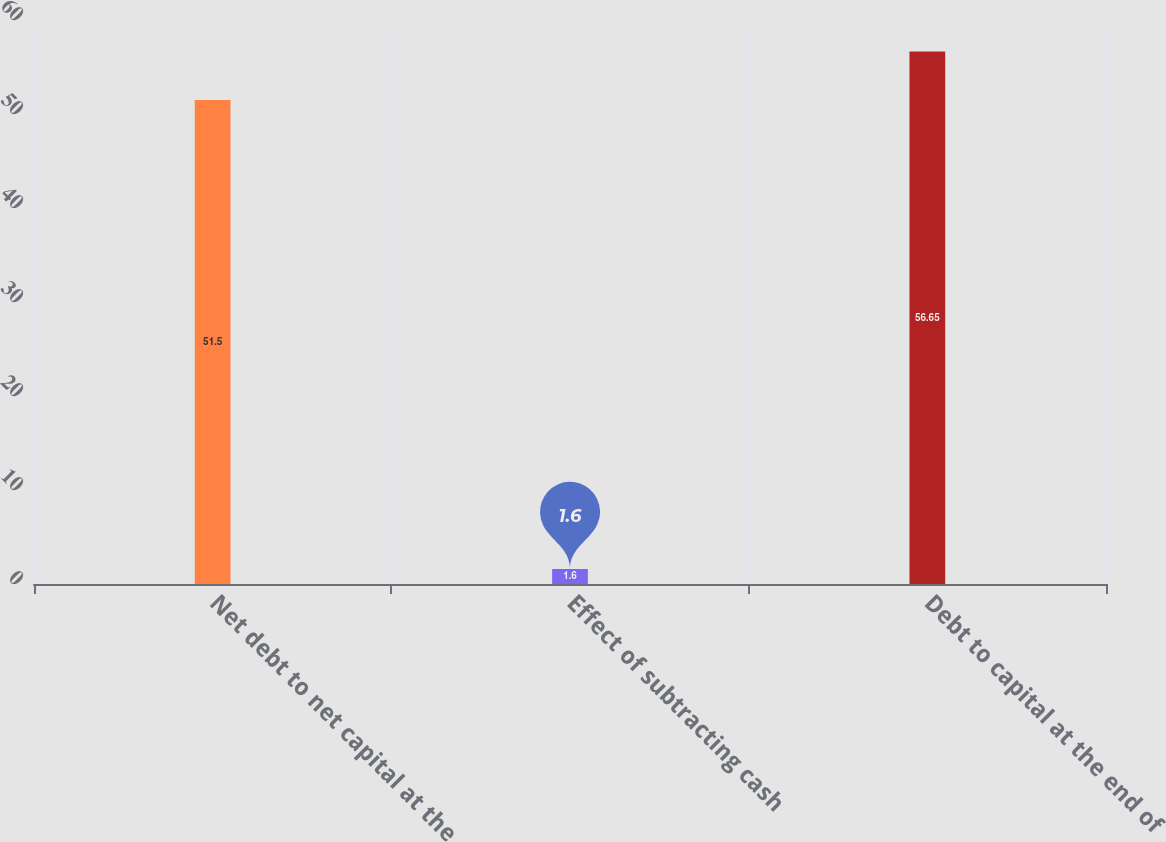<chart> <loc_0><loc_0><loc_500><loc_500><bar_chart><fcel>Net debt to net capital at the<fcel>Effect of subtracting cash<fcel>Debt to capital at the end of<nl><fcel>51.5<fcel>1.6<fcel>56.65<nl></chart> 